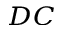<formula> <loc_0><loc_0><loc_500><loc_500>_ { D C }</formula> 